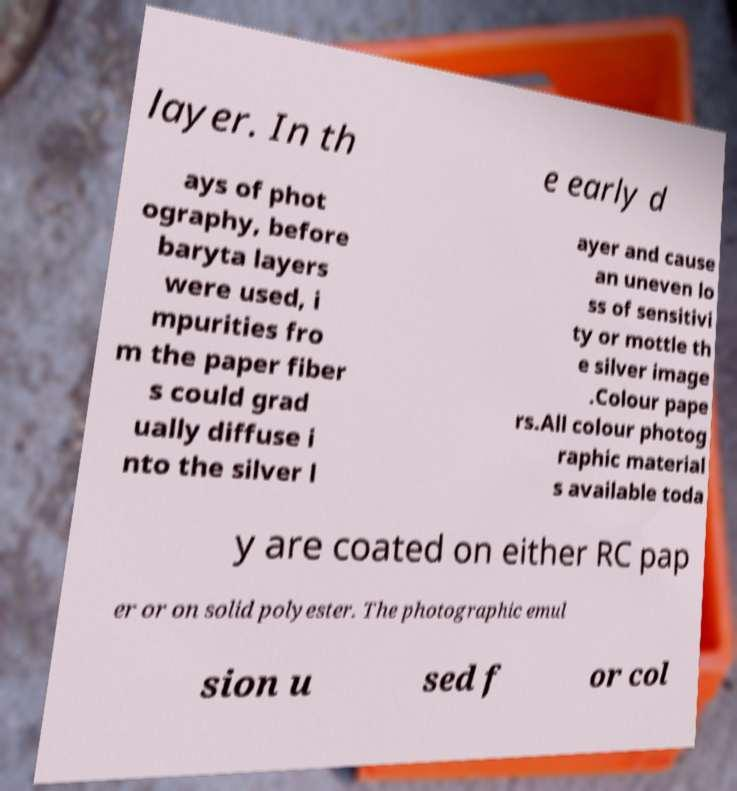I need the written content from this picture converted into text. Can you do that? layer. In th e early d ays of phot ography, before baryta layers were used, i mpurities fro m the paper fiber s could grad ually diffuse i nto the silver l ayer and cause an uneven lo ss of sensitivi ty or mottle th e silver image .Colour pape rs.All colour photog raphic material s available toda y are coated on either RC pap er or on solid polyester. The photographic emul sion u sed f or col 